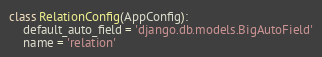Convert code to text. <code><loc_0><loc_0><loc_500><loc_500><_Python_>class RelationConfig(AppConfig):
    default_auto_field = 'django.db.models.BigAutoField'
    name = 'relation'
</code> 